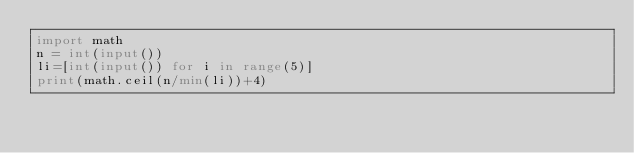Convert code to text. <code><loc_0><loc_0><loc_500><loc_500><_Python_>import math
n = int(input())
li=[int(input()) for i in range(5)]
print(math.ceil(n/min(li))+4)</code> 